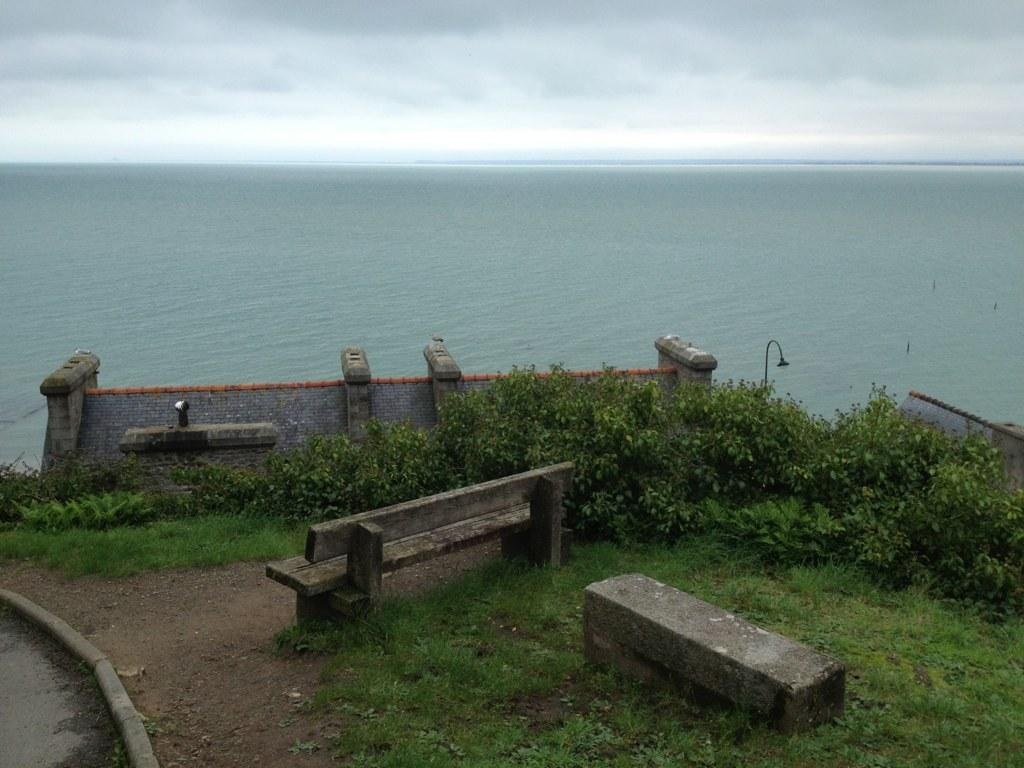What type of seating is present in the image? There is a bench in the image. What type of vegetation can be seen in the image? There is grass and plants in the image. What type of structure is present in the image? There is a wall in the image. What type of man-made object is present in the image? There is a light pole in the image. What natural element is visible in the background of the image? The background of the image includes water. What is visible in the sky in the image? The sky is visible in the background of the image, and it is cloudy. What is the weight of the apples on the bench in the image? There are no apples present in the image, so we cannot determine their weight. What caused the cloudy sky in the image? The cause of the cloudy sky is not visible or mentioned in the image, so we cannot determine the cause. 